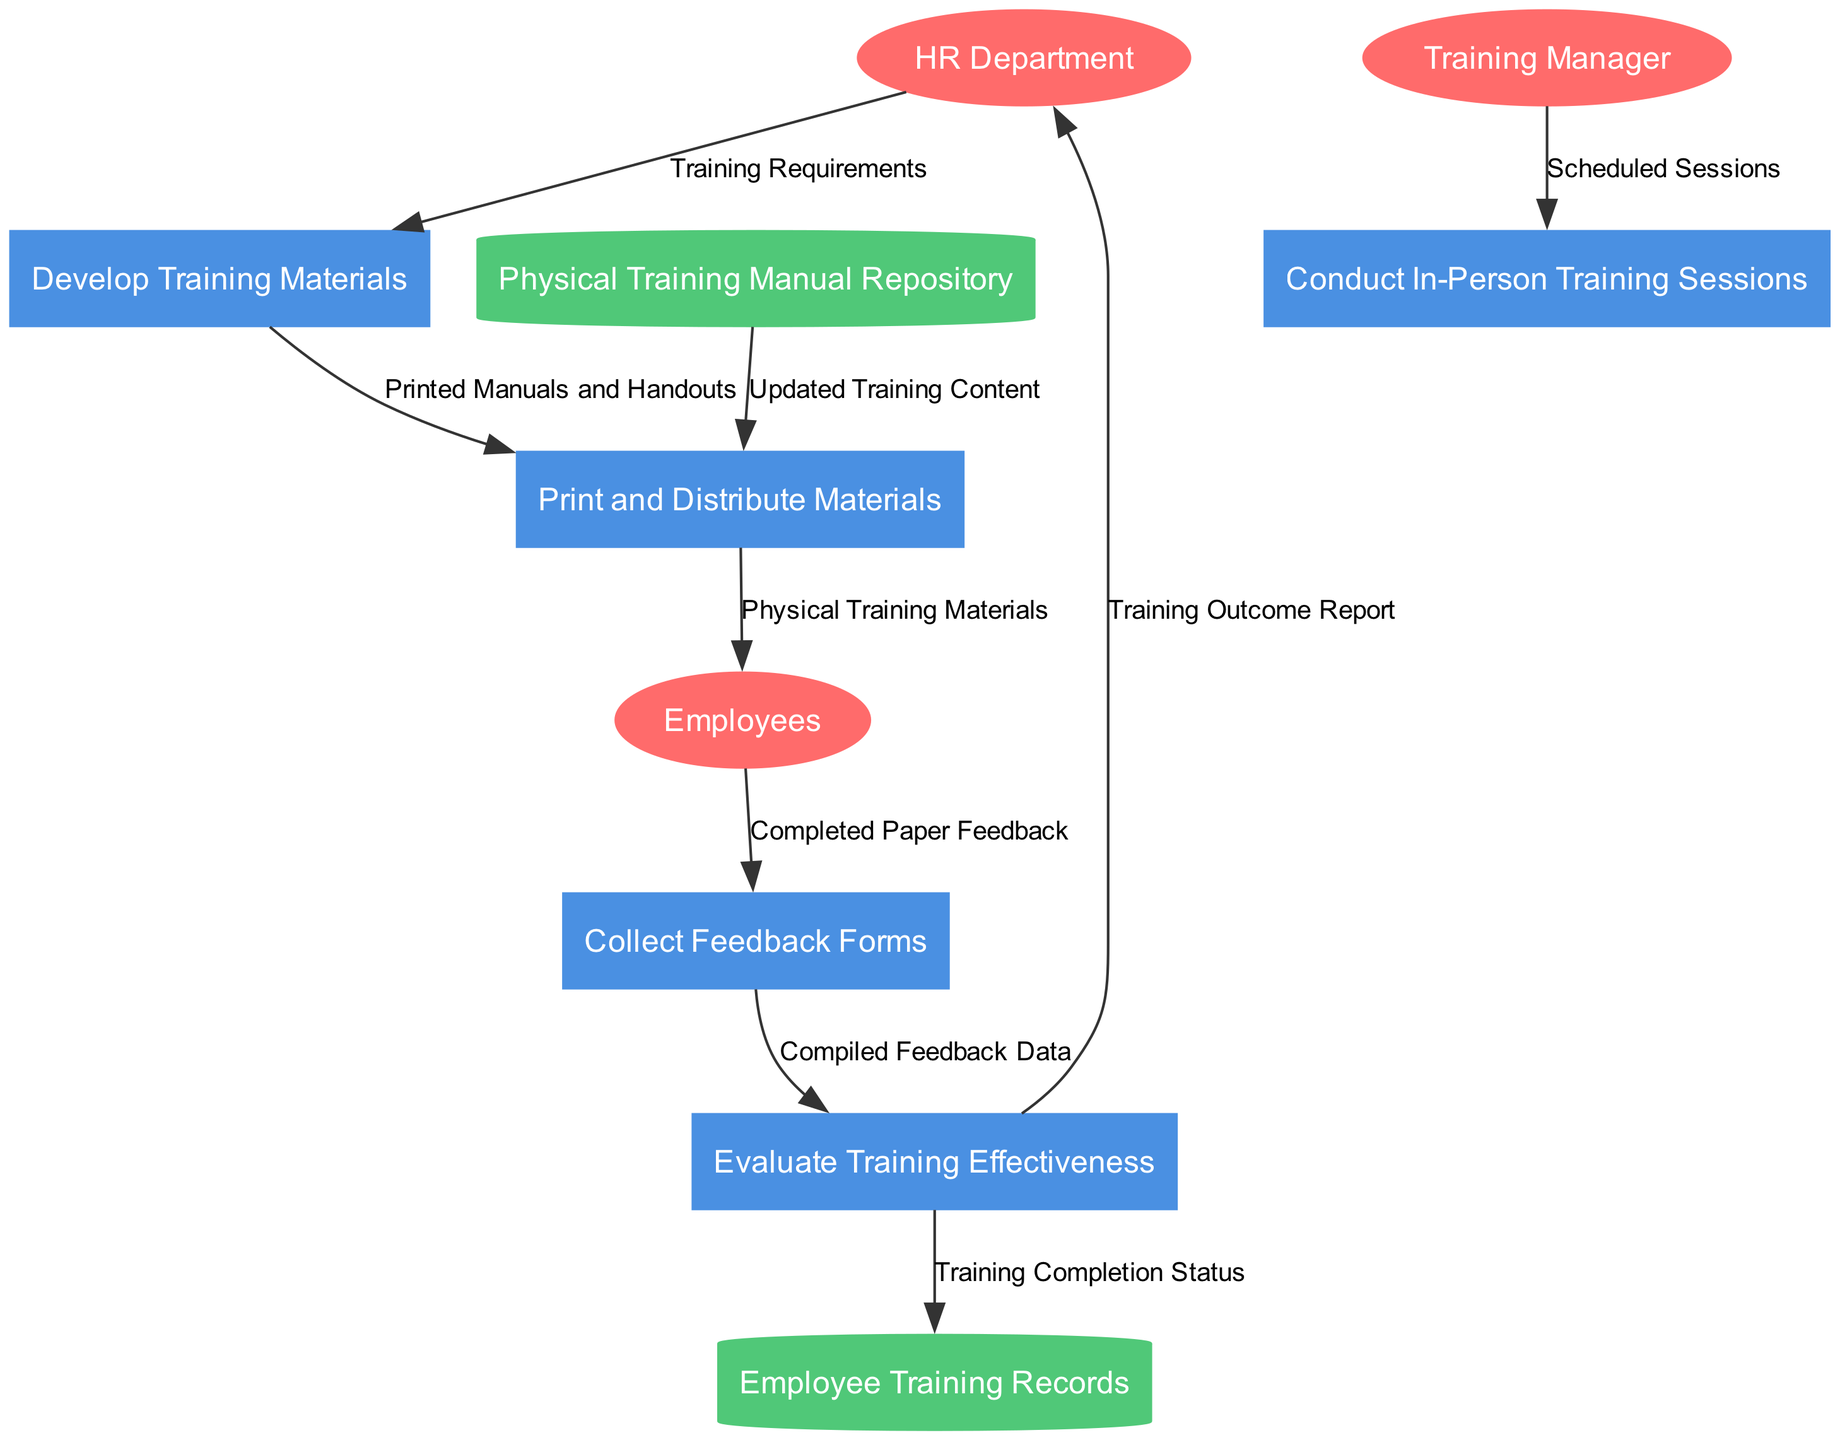What are the external entities in the diagram? The external entities are listed in the diagram. They include HR Department, Training Manager, and Employees. This information can be found in the "external_entities" section of the data, which directly corresponds to the agents interacting with the system.
Answer: HR Department, Training Manager, Employees How many processes are depicted in the diagram? The diagram includes processes that are represented as nodes. By counting the items in the "processes" section of the provided data, we find there are five distinct processes.
Answer: 5 What is the data flow from the HR Department to the Develop Training Materials process? The data flow from the HR Department leads to the Develop Training Materials process, labeled "Training Requirements." This is explicitly stated in the data flows section where it shows the source and destination along with a label for the flow.
Answer: Training Requirements Which data store is used to retrieve updated training content for printing materials? The data store used to retrieve updated training content is the Physical Training Manual Repository. This is determined by analyzing the data flows, particularly the one that shows the connection between the data store and the Print and Distribute Materials process.
Answer: Physical Training Manual Repository What data flow is associated with the process of evaluating training effectiveness? The Evaluate Training Effectiveness process is associated with multiple data flows, including "Compiled Feedback Data" flowing from Collect Feedback Forms and "Training Completion Status" flowing to Employee Training Records. This exploration of multiple flows reveals important interactions related to evaluation.
Answer: Compiled Feedback Data, Training Completion Status How many data stores are present in the diagram? The diagram features two data stores, indicated by the "data_stores" section in the provided data. Each data store is represented visually as a cylindrical node in the diagram.
Answer: 2 What information is sent to the HR Department from the Evaluate Training Effectiveness process? The information sent to the HR Department is labeled as "Training Outcome Report." It is indicated in the data flows section, highlighting the final output of the evaluation process.
Answer: Training Outcome Report What feedback is collected from Employees? The feedback collected from Employees is in the form of "Completed Paper Feedback." This input is indicated in the data flow from Employees to the Collect Feedback Forms process, showing what is gathered from the training attendees.
Answer: Completed Paper Feedback What role does the Training Manager play in the diagram? The Training Manager is responsible for the "Conduct In-Person Training Sessions" process, as indicated by the data flow labeled "Scheduled Sessions" connecting the Training Manager and this process. This signifies the Training Manager's direct involvement in organizing and executing training sessions.
Answer: Conduct In-Person Training Sessions 